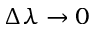<formula> <loc_0><loc_0><loc_500><loc_500>\Delta \lambda \rightarrow 0</formula> 